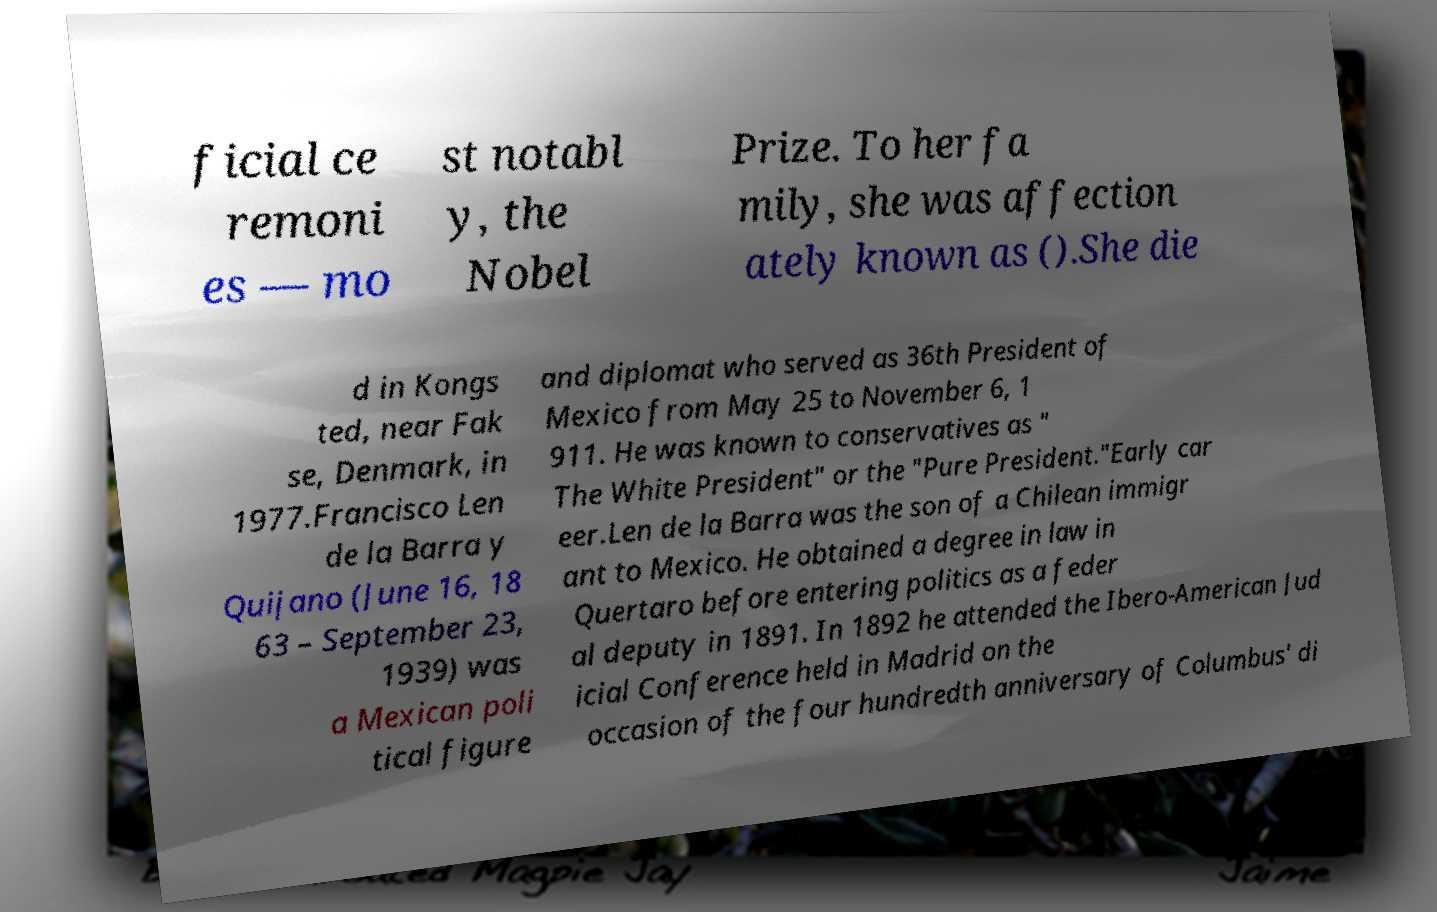Please read and relay the text visible in this image. What does it say? ficial ce remoni es — mo st notabl y, the Nobel Prize. To her fa mily, she was affection ately known as ().She die d in Kongs ted, near Fak se, Denmark, in 1977.Francisco Len de la Barra y Quijano (June 16, 18 63 – September 23, 1939) was a Mexican poli tical figure and diplomat who served as 36th President of Mexico from May 25 to November 6, 1 911. He was known to conservatives as " The White President" or the "Pure President."Early car eer.Len de la Barra was the son of a Chilean immigr ant to Mexico. He obtained a degree in law in Quertaro before entering politics as a feder al deputy in 1891. In 1892 he attended the Ibero-American Jud icial Conference held in Madrid on the occasion of the four hundredth anniversary of Columbus' di 